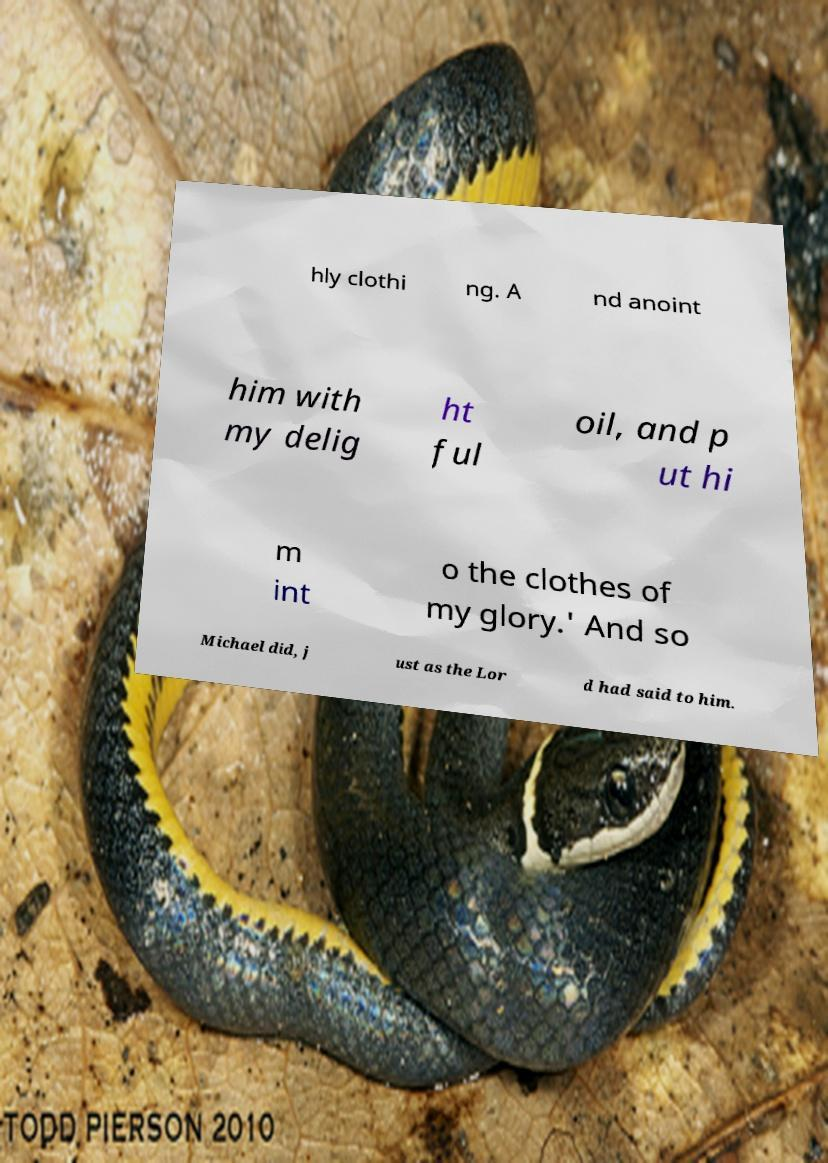Please identify and transcribe the text found in this image. hly clothi ng. A nd anoint him with my delig ht ful oil, and p ut hi m int o the clothes of my glory.' And so Michael did, j ust as the Lor d had said to him. 